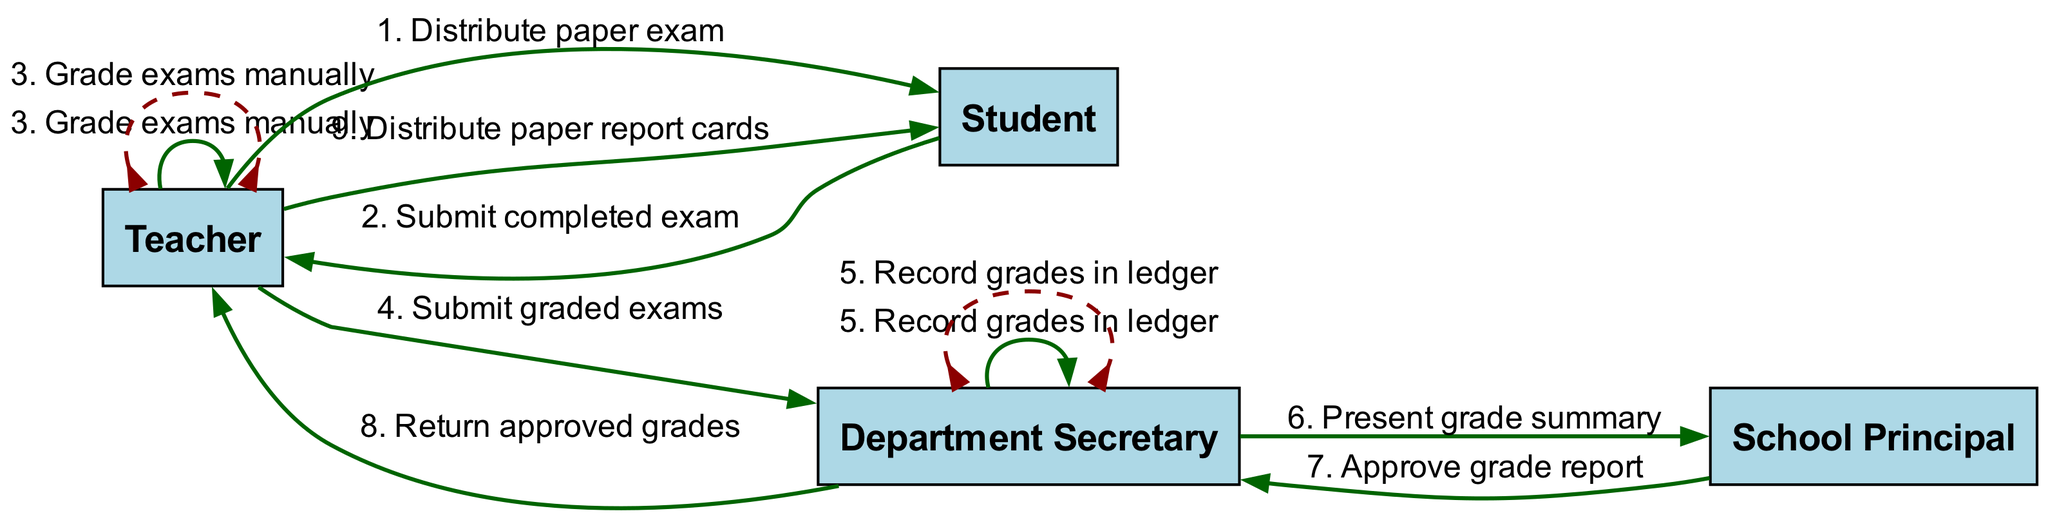What is the first action in the sequence diagram? The first action in the sequence diagram is "Distribute paper exam," which is initiated by the Teacher directed to the Student.
Answer: Distribute paper exam How many actors are involved in the workflow? There are four actors involved in the workflow: Teacher, Student, Department Secretary, and School Principal.
Answer: Four What action does the Teacher perform after grading exams? After grading exams, the Teacher submits the graded exams to the Department Secretary.
Answer: Submit graded exams Who approves the grade report? The School Principal is responsible for approving the grade report presented by the Department Secretary.
Answer: School Principal What is the total number of actions depicted in the diagram? There are a total of nine actions shown in the sequence diagram, each representing a step in the grading and result distribution workflow.
Answer: Nine Which actor records grades in the ledger? The Department Secretary records grades in the ledger after receiving the graded exams from the Teacher.
Answer: Department Secretary What is the last action in the workflow? The last action in the workflow is "Distribute paper report cards," carried out by the Teacher to the Student.
Answer: Distribute paper report cards What type of action is performed by the Department Secretary to the Department Secretary? The action recorded by the Department Secretary is self-referential, specifically "Record grades in ledger," indicating that it is done internally by this actor.
Answer: Record grades in ledger How many actions are performed by the Teacher? The Teacher performs four distinct actions throughout the workflow: Distribute paper exam, Submit completed exam, Grade exams manually, and Distribute paper report cards.
Answer: Four 